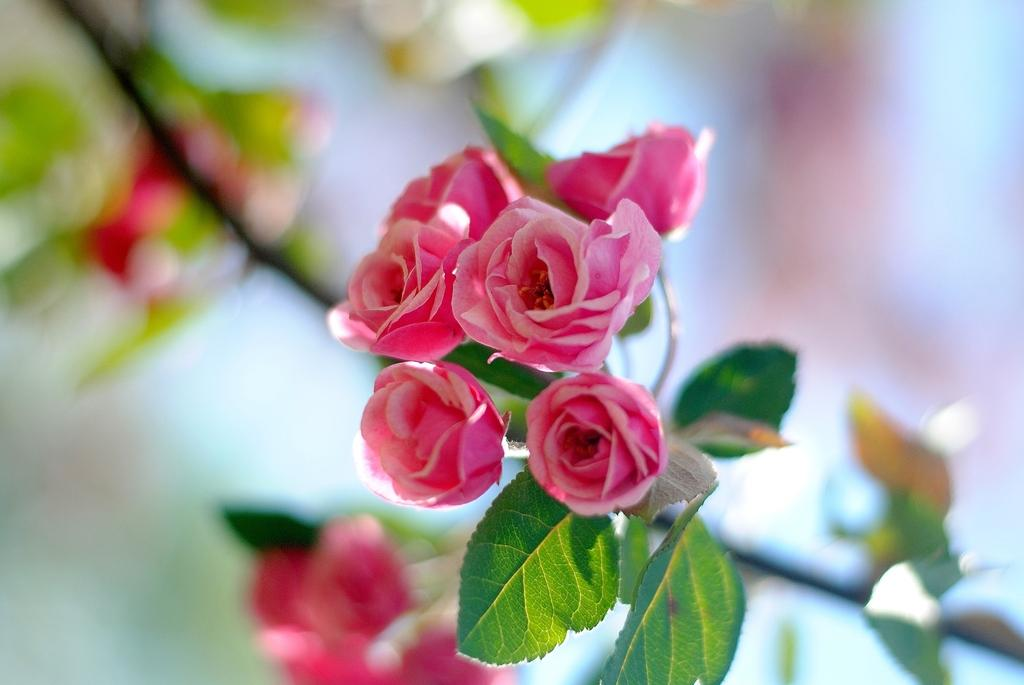What type of flowers are in the foreground of the image? There are rose flowers in the foreground of the image. What other plant elements can be seen in the image? There are leaves in the image. How would you describe the background of the image? The background of the image is blurry. Can you tell me how many guides are present in the image? There are no guides present in the image; it features rose flowers and leaves. What type of giants can be seen in the image? There are no giants present in the image; it features rose flowers and leaves. 